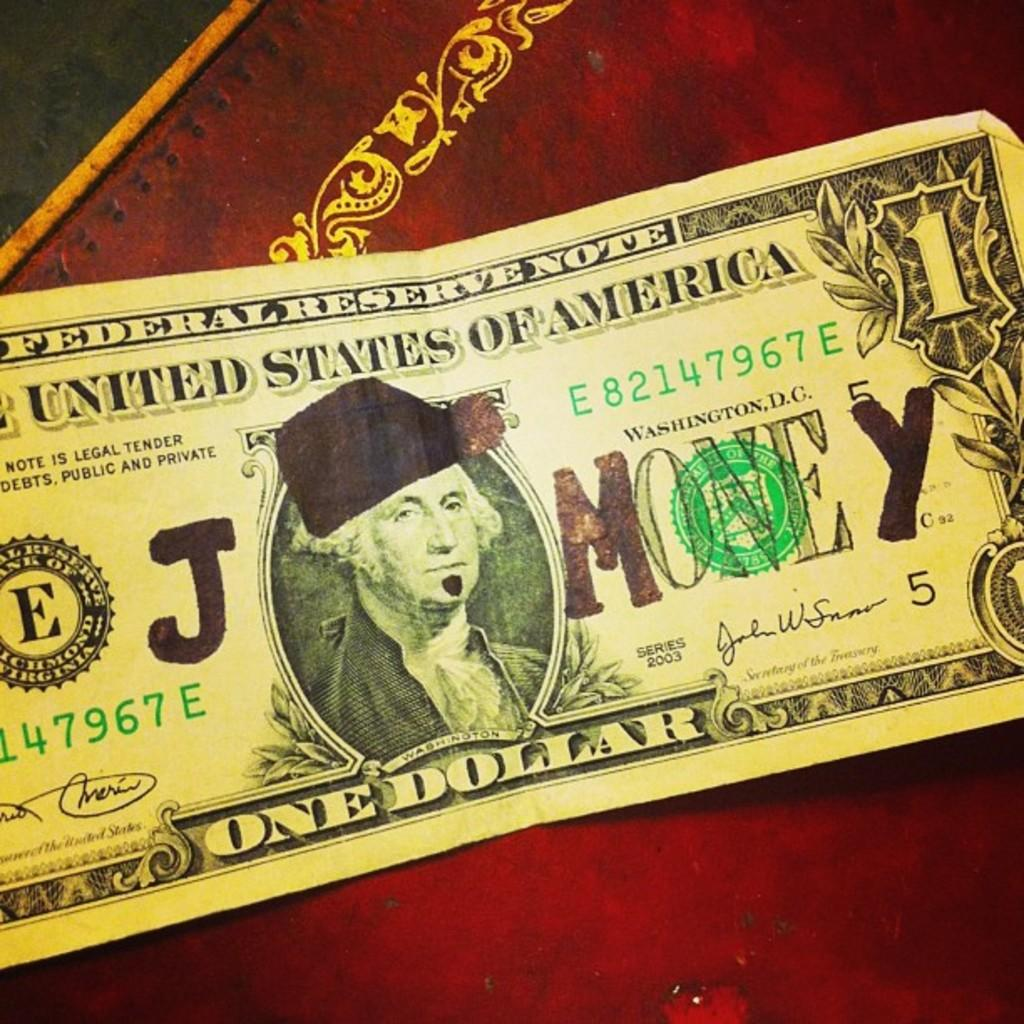What is the main subject of the image? The main subject of the image is an American dollar. Where is the American dollar located in the image? The American dollar is on the moon surface in the image. What can be seen at the top of the image? There is a design visible at the top of the image, and it is in black color. What type of object is present at the top of the image? There is a wooden object at the top of the image. Can you tell me how many giraffes are visible in the image? There are no giraffes present in the image. What did the mom say about the American dollar in the image? There is no reference to a mom or any spoken words in the image, so it is not possible to answer that question. 